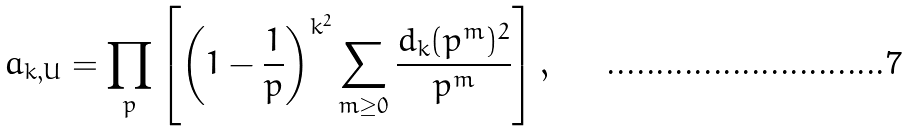<formula> <loc_0><loc_0><loc_500><loc_500>a _ { k , U } = \prod _ { p } \left [ \left ( 1 - \frac { 1 } { p } \right ) ^ { k ^ { 2 } } \sum _ { m \geq 0 } \frac { d _ { k } ( p ^ { m } ) ^ { 2 } } { p ^ { m } } \right ] ,</formula> 